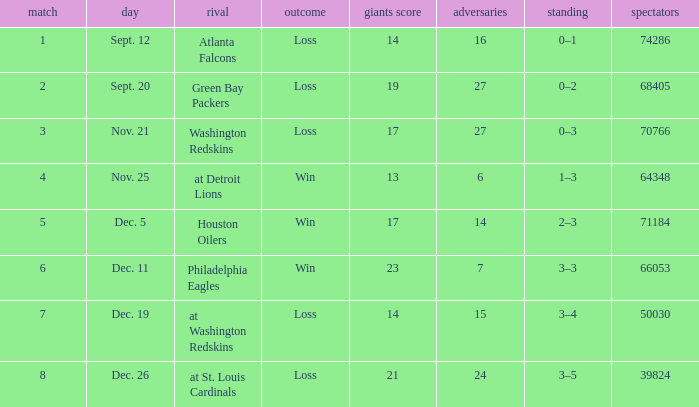What is the minimum number of opponents? 6.0. 